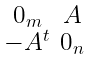Convert formula to latex. <formula><loc_0><loc_0><loc_500><loc_500>\begin{smallmatrix} 0 _ { m } & A \\ - A ^ { t } & 0 _ { n } \end{smallmatrix}</formula> 